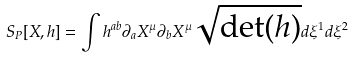<formula> <loc_0><loc_0><loc_500><loc_500>S _ { P } [ X , h ] = \int h ^ { a b } \partial _ { a } X ^ { \mu } \partial _ { b } X ^ { \mu } \sqrt { \det ( h ) } d \xi ^ { 1 } d \xi ^ { 2 }</formula> 